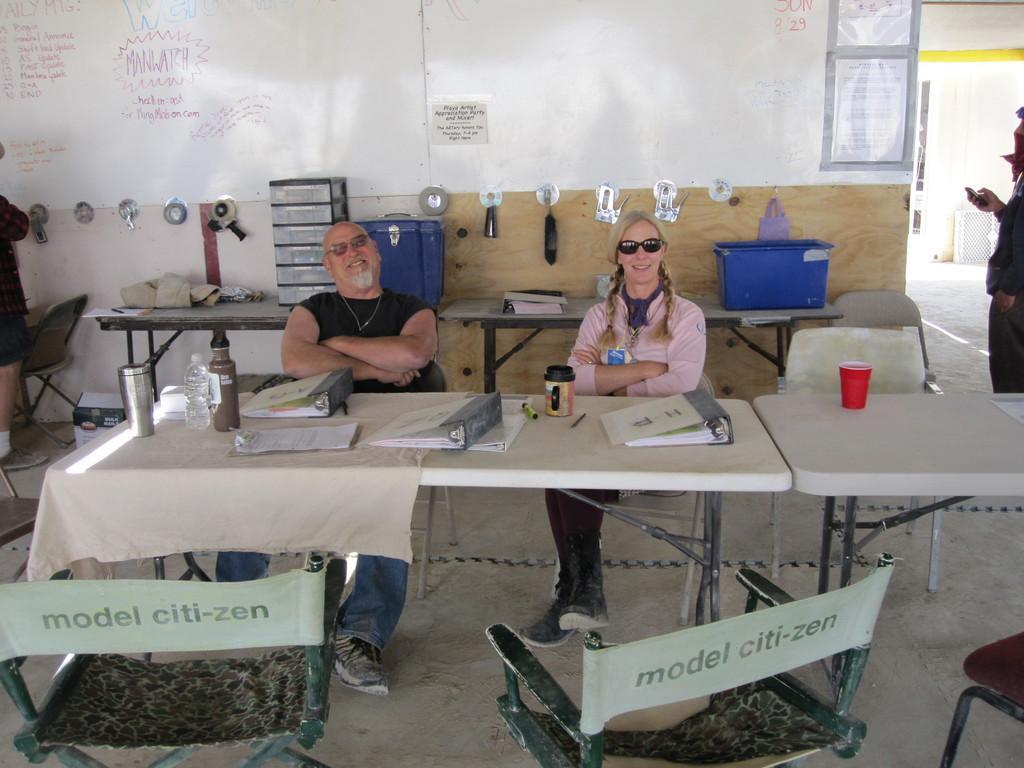Could you give a brief overview of what you see in this image? In this picture we can see two people sitting on the chairs in front of the table on which we have a file and a bottle and a glass and behind them there is a dash on which some things are placed in front of them there are two chairs. 